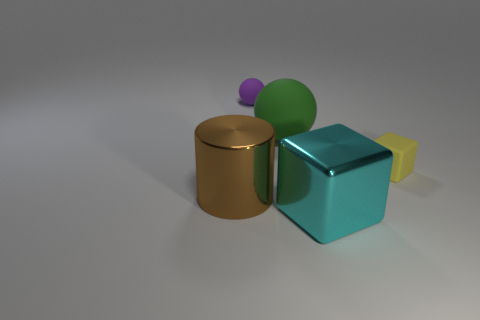Do the cyan shiny thing and the purple object have the same shape?
Your answer should be compact. No. There is another thing that is the same shape as the large green thing; what size is it?
Provide a succinct answer. Small. Are there more spheres that are right of the purple object than purple rubber objects to the right of the large matte sphere?
Your response must be concise. Yes. Is the material of the yellow cube the same as the ball behind the large green ball?
Offer a very short reply. Yes. Is there any other thing that has the same shape as the brown object?
Keep it short and to the point. No. There is a thing that is both left of the matte block and right of the big sphere; what color is it?
Make the answer very short. Cyan. There is a thing that is on the right side of the cyan metallic cube; what is its shape?
Offer a very short reply. Cube. What is the size of the block behind the shiny thing that is behind the big shiny thing to the right of the shiny cylinder?
Make the answer very short. Small. There is a large thing that is to the left of the big rubber thing; how many objects are on the right side of it?
Offer a very short reply. 4. How big is the object that is both left of the big rubber ball and behind the yellow matte block?
Your response must be concise. Small. 